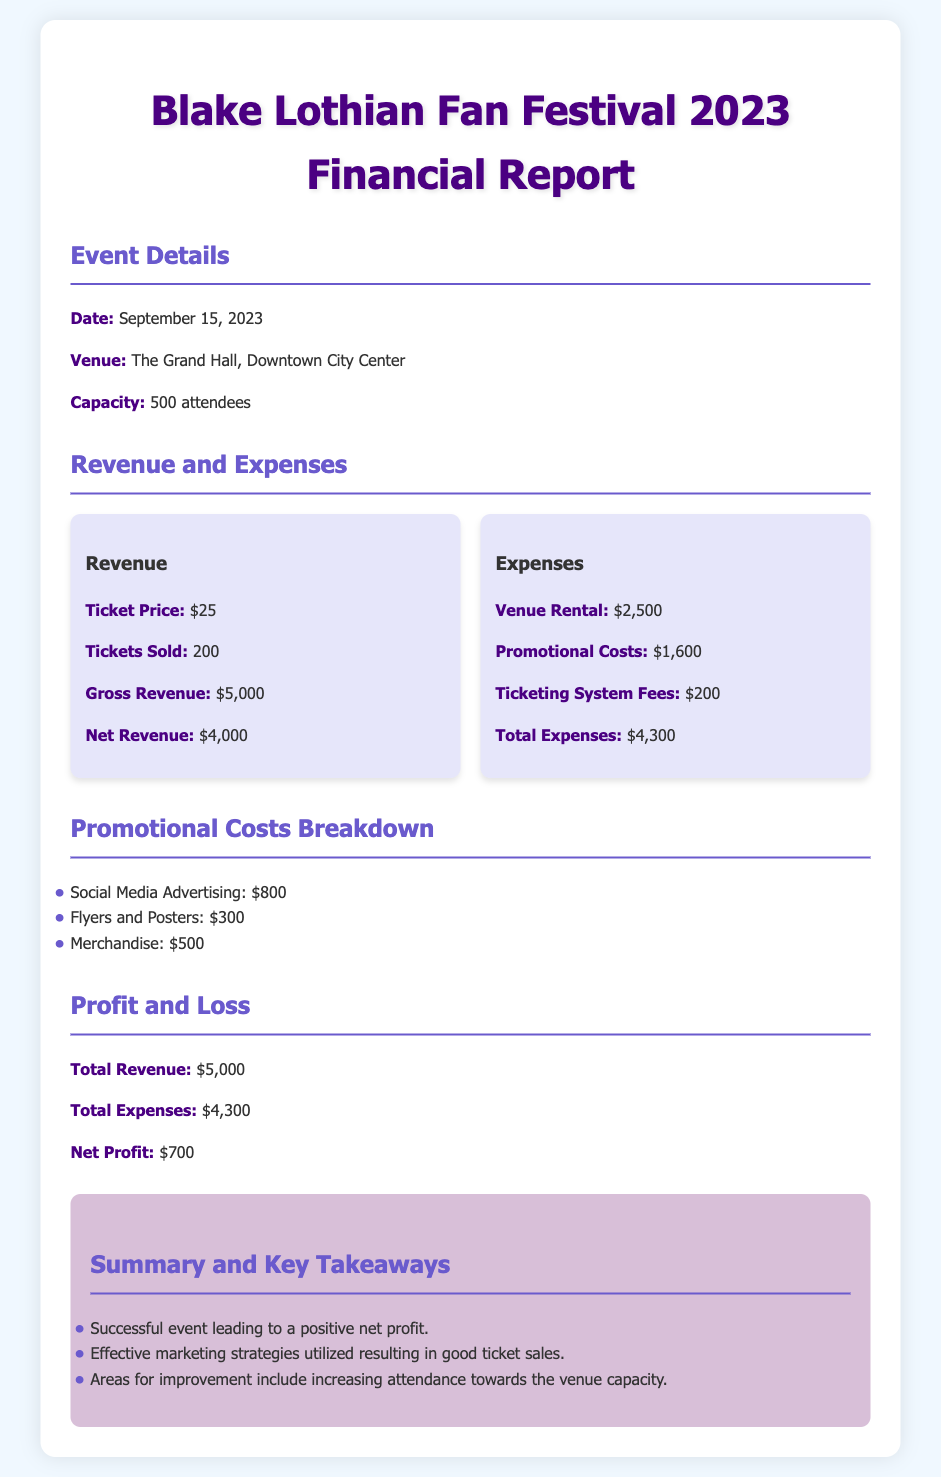What was the date of the event? The document states that the event took place on September 15, 2023.
Answer: September 15, 2023 What was the venue of the event? The venue for the fan festival is specified as The Grand Hall, Downtown City Center.
Answer: The Grand Hall, Downtown City Center What were the total expenses? Total expenses in the report are detailed as $4,300.
Answer: $4,300 What was the net profit from the event? The net profit calculated in the document is $700, which is the difference between total revenue and total expenses.
Answer: $700 How many tickets were sold for the event? The financial report indicates that 200 tickets were sold.
Answer: 200 What was the cost of venue rental? Venue rental expenses are listed as $2,500 in the report.
Answer: $2,500 What was the total promotional costs? The total promotional costs are provided as $1,600.
Answer: $1,600 What was the ticket price? The document specifies the ticket price as $25.
Answer: $25 What is the capacity of the venue? The capacity of the venue for the event is stated as 500 attendees.
Answer: 500 